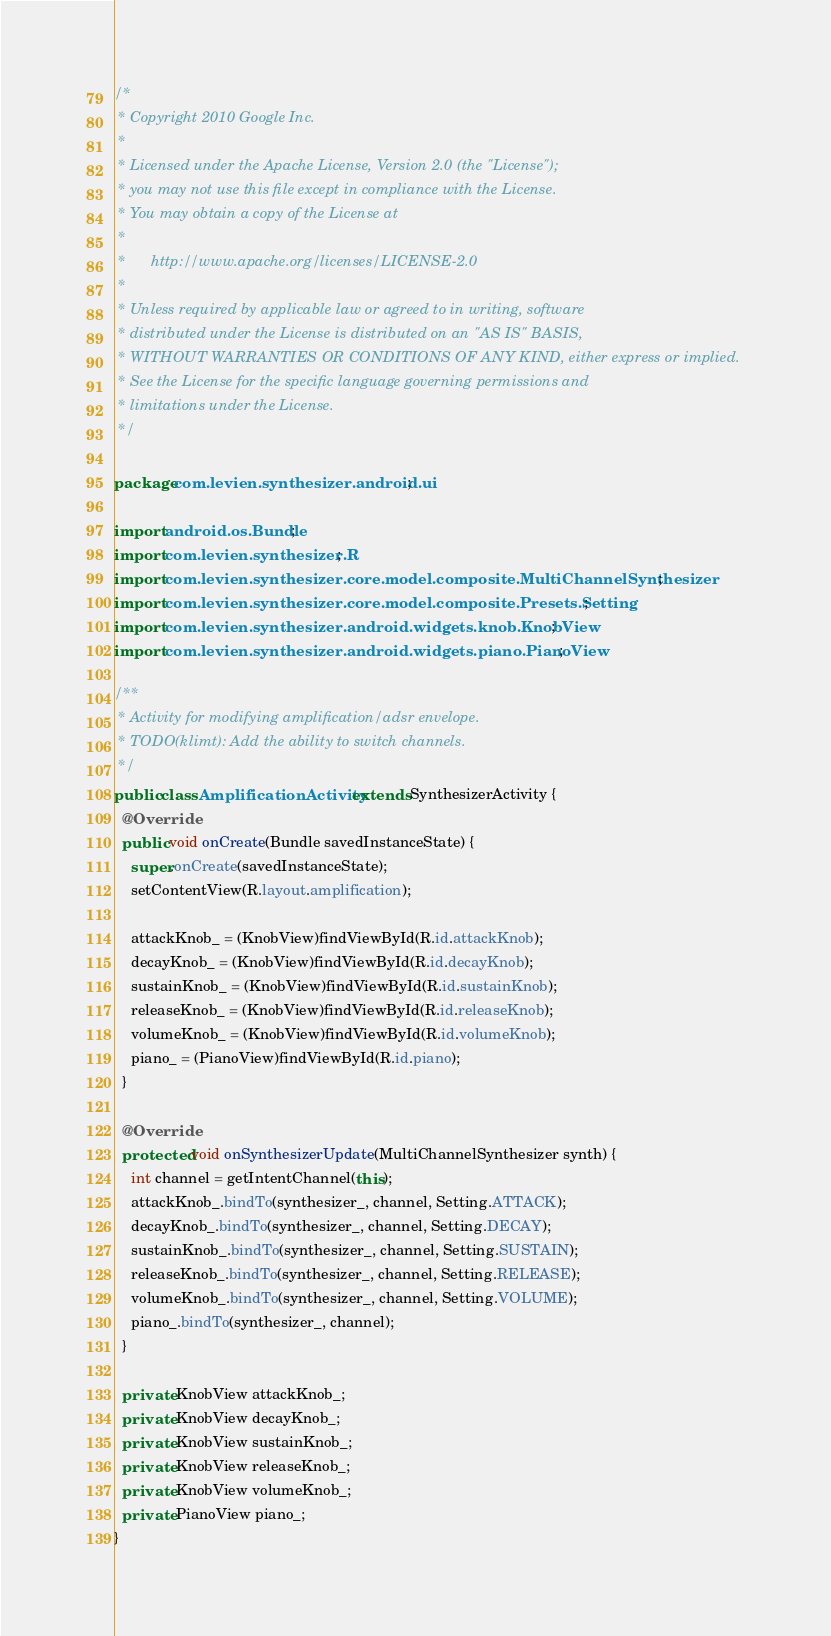Convert code to text. <code><loc_0><loc_0><loc_500><loc_500><_Java_>/*
 * Copyright 2010 Google Inc.
 * 
 * Licensed under the Apache License, Version 2.0 (the "License");
 * you may not use this file except in compliance with the License.
 * You may obtain a copy of the License at
 * 
 *      http://www.apache.org/licenses/LICENSE-2.0
 * 
 * Unless required by applicable law or agreed to in writing, software
 * distributed under the License is distributed on an "AS IS" BASIS,
 * WITHOUT WARRANTIES OR CONDITIONS OF ANY KIND, either express or implied.
 * See the License for the specific language governing permissions and
 * limitations under the License.
 */

package com.levien.synthesizer.android.ui;

import android.os.Bundle;
import com.levien.synthesizer.R;
import com.levien.synthesizer.core.model.composite.MultiChannelSynthesizer;
import com.levien.synthesizer.core.model.composite.Presets.Setting;
import com.levien.synthesizer.android.widgets.knob.KnobView;
import com.levien.synthesizer.android.widgets.piano.PianoView;

/**
 * Activity for modifying amplification/adsr envelope.
 * TODO(klimt): Add the ability to switch channels.
 */
public class AmplificationActivity extends SynthesizerActivity {
  @Override
  public void onCreate(Bundle savedInstanceState) {
    super.onCreate(savedInstanceState);
    setContentView(R.layout.amplification);

    attackKnob_ = (KnobView)findViewById(R.id.attackKnob);
    decayKnob_ = (KnobView)findViewById(R.id.decayKnob);
    sustainKnob_ = (KnobView)findViewById(R.id.sustainKnob);
    releaseKnob_ = (KnobView)findViewById(R.id.releaseKnob);
    volumeKnob_ = (KnobView)findViewById(R.id.volumeKnob);
    piano_ = (PianoView)findViewById(R.id.piano);
  }

  @Override
  protected void onSynthesizerUpdate(MultiChannelSynthesizer synth) {
    int channel = getIntentChannel(this);
    attackKnob_.bindTo(synthesizer_, channel, Setting.ATTACK);
    decayKnob_.bindTo(synthesizer_, channel, Setting.DECAY);
    sustainKnob_.bindTo(synthesizer_, channel, Setting.SUSTAIN);
    releaseKnob_.bindTo(synthesizer_, channel, Setting.RELEASE);
    volumeKnob_.bindTo(synthesizer_, channel, Setting.VOLUME);
    piano_.bindTo(synthesizer_, channel);
  }

  private KnobView attackKnob_;
  private KnobView decayKnob_;
  private KnobView sustainKnob_;
  private KnobView releaseKnob_;
  private KnobView volumeKnob_;
  private PianoView piano_;
}
</code> 